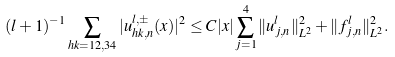<formula> <loc_0><loc_0><loc_500><loc_500>( l + 1 ) ^ { - 1 } \sum _ { h k = 1 2 , 3 4 } | u ^ { l , \pm } _ { h k , n } ( x ) | ^ { 2 } \leq C | x | \sum _ { j = 1 } ^ { 4 } \| u _ { j , n } ^ { l } \| _ { L ^ { 2 } } ^ { 2 } + \| f _ { j , n } ^ { l } \| _ { L ^ { 2 } } ^ { 2 } .</formula> 